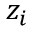<formula> <loc_0><loc_0><loc_500><loc_500>z _ { i }</formula> 